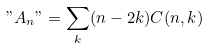Convert formula to latex. <formula><loc_0><loc_0><loc_500><loc_500>" A _ { n } " = \sum _ { k } ( n - 2 k ) C ( n , k )</formula> 